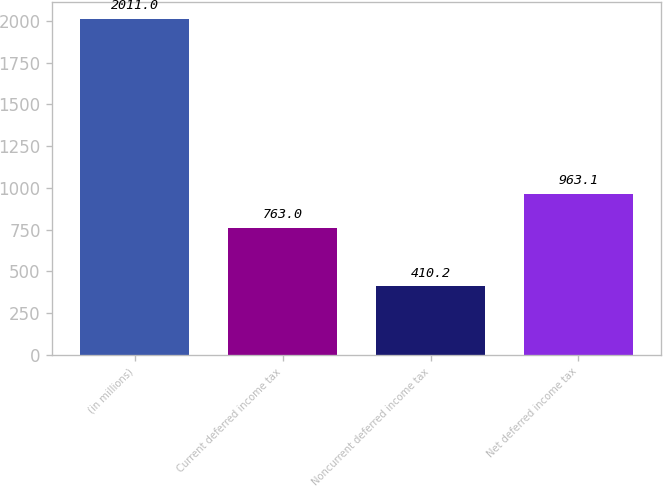Convert chart. <chart><loc_0><loc_0><loc_500><loc_500><bar_chart><fcel>(in millions)<fcel>Current deferred income tax<fcel>Noncurrent deferred income tax<fcel>Net deferred income tax<nl><fcel>2011<fcel>763<fcel>410.2<fcel>963.1<nl></chart> 